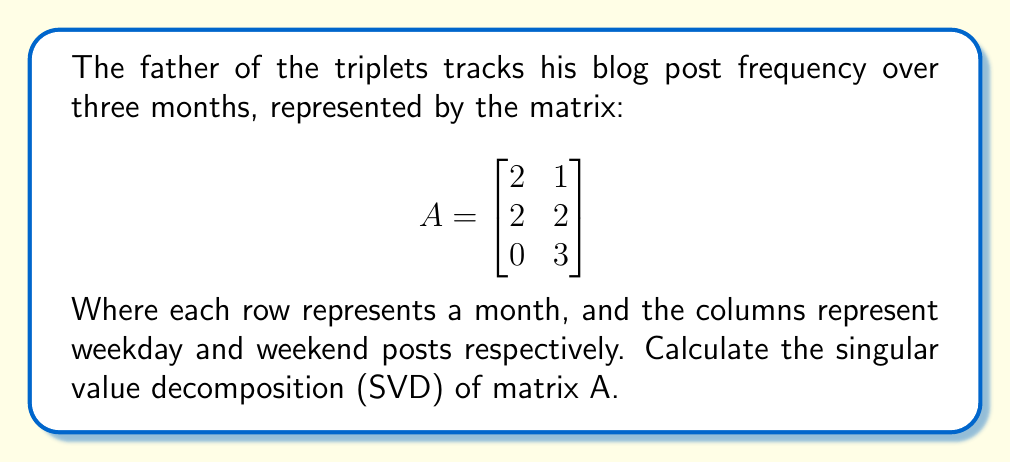Teach me how to tackle this problem. To find the singular value decomposition of matrix A, we need to find matrices U, Σ, and V such that A = UΣV^T.

Step 1: Calculate A^T A and AA^T
$$A^T A = \begin{bmatrix}
2 & 2 & 0 \\
1 & 2 & 3
\end{bmatrix} \begin{bmatrix}
2 & 1 \\
2 & 2 \\
0 & 3
\end{bmatrix} = \begin{bmatrix}
8 & 6 \\
6 & 14
\end{bmatrix}$$

$$AA^T = \begin{bmatrix}
2 & 1 \\
2 & 2 \\
0 & 3
\end{bmatrix} \begin{bmatrix}
2 & 2 & 0 \\
1 & 2 & 3
\end{bmatrix} = \begin{bmatrix}
5 & 6 & 3 \\
6 & 8 & 6 \\
3 & 6 & 9
\end{bmatrix}$$

Step 2: Find eigenvalues of A^T A (which are the squares of singular values)
Characteristic equation: $\det(A^T A - \lambda I) = \begin{vmatrix}
8-\lambda & 6 \\
6 & 14-\lambda
\end{vmatrix} = (8-\lambda)(14-\lambda) - 36 = \lambda^2 - 22\lambda + 76 = 0$

Solving this equation: $\lambda_1 = 18.54, \lambda_2 = 3.46$

Step 3: Calculate singular values
$\sigma_1 = \sqrt{18.54} \approx 4.31, \sigma_2 = \sqrt{3.46} \approx 1.86$

Step 4: Find right singular vectors (eigenvectors of A^T A)
For $\lambda_1 = 18.54$:
$(A^T A - 18.54I)v_1 = 0$
Solving this, we get: $v_1 \approx [0.52, 0.85]^T$

For $\lambda_2 = 3.46$:
$(A^T A - 3.46I)v_2 = 0$
Solving this, we get: $v_2 \approx [-0.85, 0.52]^T$

Step 5: Find left singular vectors
$u_1 = \frac{1}{\sigma_1}Av_1 \approx [0.37, 0.60, 0.71]^T$
$u_2 = \frac{1}{\sigma_2}Av_2 \approx [0.60, 0.00, -0.80]^T$

Step 6: Construct U, Σ, and V matrices
$$U \approx \begin{bmatrix}
0.37 & 0.60 & 0.71 \\
0.60 & 0.00 & -0.80 \\
0.71 & -0.80 & 0.09
\end{bmatrix}$$

$$\Sigma = \begin{bmatrix}
4.31 & 0 \\
0 & 1.86 \\
0 & 0
\end{bmatrix}$$

$$V \approx \begin{bmatrix}
0.52 & -0.85 \\
0.85 & 0.52
\end{bmatrix}$$
Answer: A ≈ UΣV^T, where U ≈ [[0.37, 0.60, 0.71], [0.60, 0.00, -0.80], [0.71, -0.80, 0.09]], Σ = [[4.31, 0], [0, 1.86], [0, 0]], V ≈ [[0.52, -0.85], [0.85, 0.52]] 